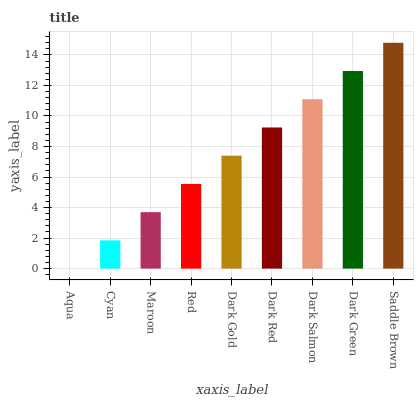Is Aqua the minimum?
Answer yes or no. Yes. Is Saddle Brown the maximum?
Answer yes or no. Yes. Is Cyan the minimum?
Answer yes or no. No. Is Cyan the maximum?
Answer yes or no. No. Is Cyan greater than Aqua?
Answer yes or no. Yes. Is Aqua less than Cyan?
Answer yes or no. Yes. Is Aqua greater than Cyan?
Answer yes or no. No. Is Cyan less than Aqua?
Answer yes or no. No. Is Dark Gold the high median?
Answer yes or no. Yes. Is Dark Gold the low median?
Answer yes or no. Yes. Is Dark Salmon the high median?
Answer yes or no. No. Is Dark Red the low median?
Answer yes or no. No. 